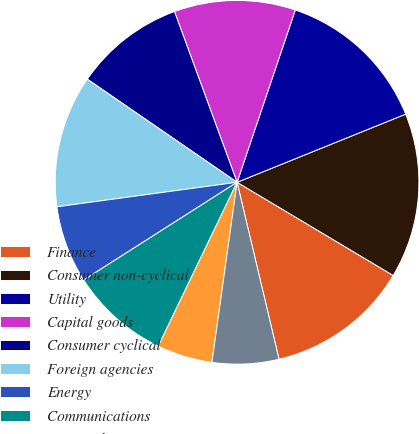Convert chart to OTSL. <chart><loc_0><loc_0><loc_500><loc_500><pie_chart><fcel>Finance<fcel>Consumer non-cyclical<fcel>Utility<fcel>Capital goods<fcel>Consumer cyclical<fcel>Foreign agencies<fcel>Energy<fcel>Communications<fcel>Basic industry<fcel>Transportation<nl><fcel>12.73%<fcel>14.68%<fcel>13.7%<fcel>10.78%<fcel>9.81%<fcel>11.75%<fcel>6.88%<fcel>8.83%<fcel>4.93%<fcel>5.91%<nl></chart> 